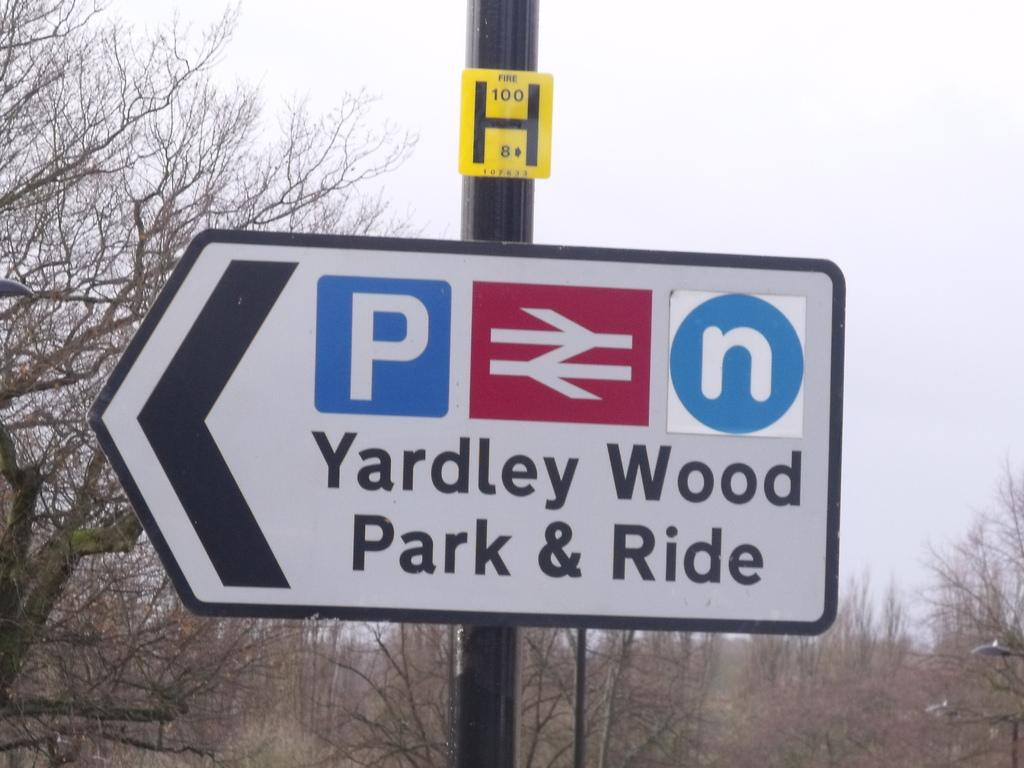<image>
Give a short and clear explanation of the subsequent image. a road sign saying Yardly Wood Park & Ride 